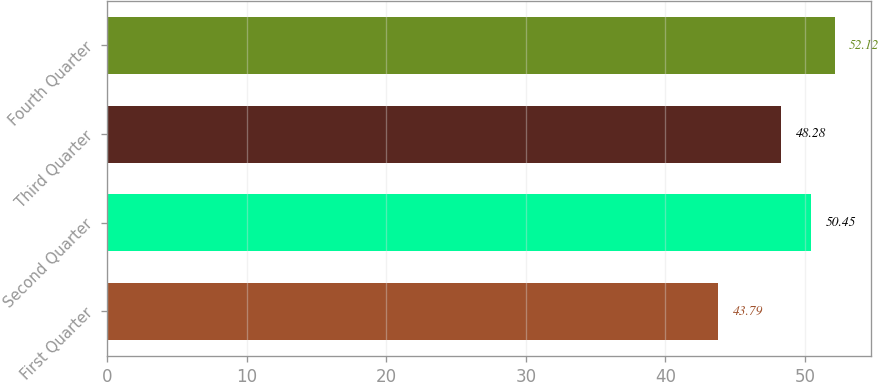Convert chart to OTSL. <chart><loc_0><loc_0><loc_500><loc_500><bar_chart><fcel>First Quarter<fcel>Second Quarter<fcel>Third Quarter<fcel>Fourth Quarter<nl><fcel>43.79<fcel>50.45<fcel>48.28<fcel>52.12<nl></chart> 